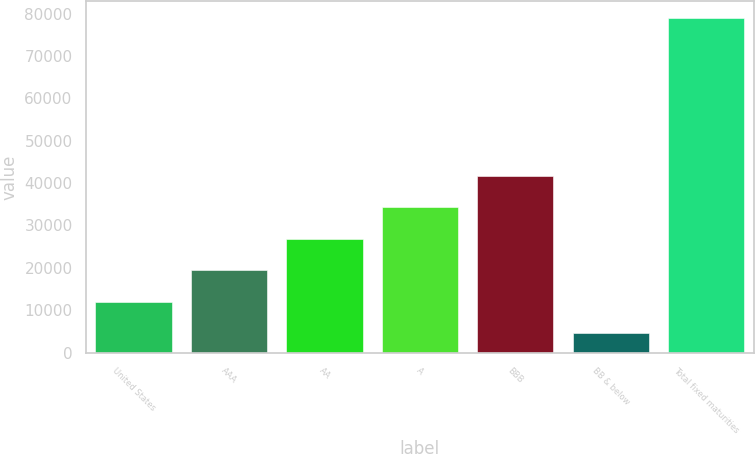Convert chart. <chart><loc_0><loc_0><loc_500><loc_500><bar_chart><fcel>United States<fcel>AAA<fcel>AA<fcel>A<fcel>BBB<fcel>BB & below<fcel>Total fixed maturities<nl><fcel>11949.6<fcel>19397.2<fcel>26844.8<fcel>34292.4<fcel>41740<fcel>4502<fcel>78978<nl></chart> 